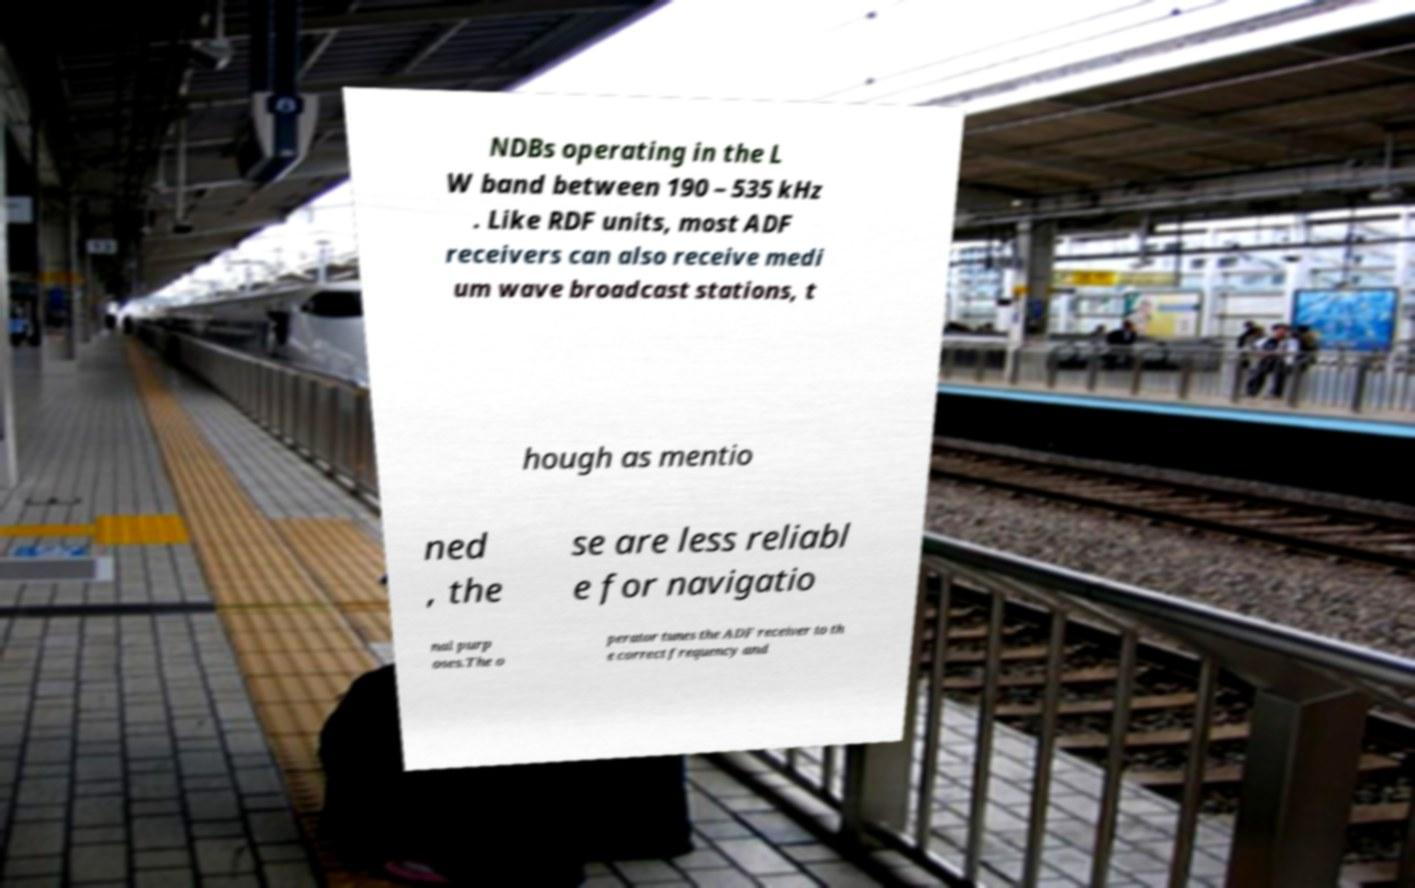Can you read and provide the text displayed in the image?This photo seems to have some interesting text. Can you extract and type it out for me? NDBs operating in the L W band between 190 – 535 kHz . Like RDF units, most ADF receivers can also receive medi um wave broadcast stations, t hough as mentio ned , the se are less reliabl e for navigatio nal purp oses.The o perator tunes the ADF receiver to th e correct frequency and 